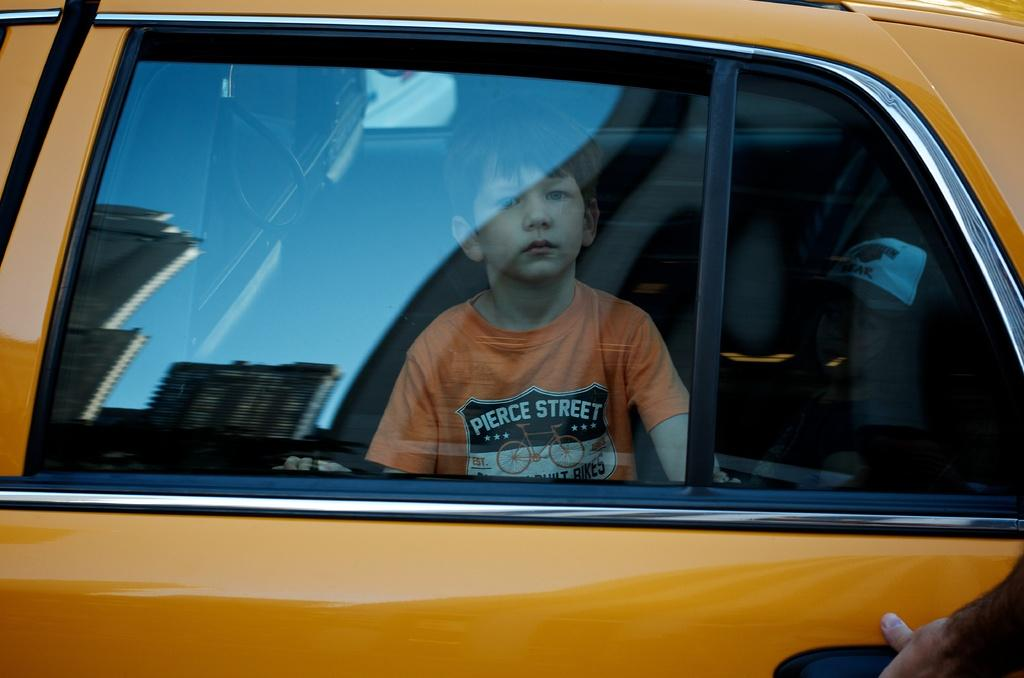<image>
Create a compact narrative representing the image presented. A boy in a Pierce Street shirt looks out of a taxi window. 